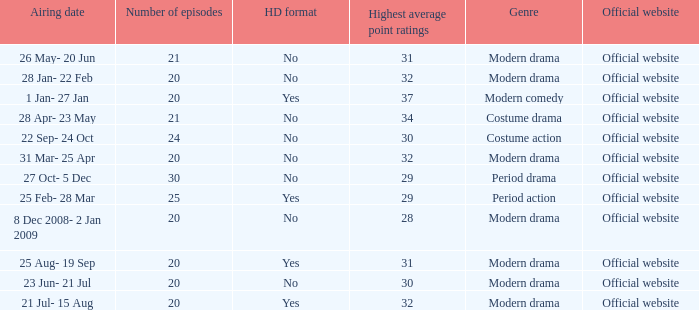What was the airing date when the number of episodes was larger than 20 and had the genre of costume action? 22 Sep- 24 Oct. 